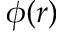Convert formula to latex. <formula><loc_0><loc_0><loc_500><loc_500>\phi ( r )</formula> 